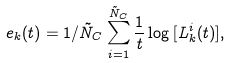Convert formula to latex. <formula><loc_0><loc_0><loc_500><loc_500>e _ { k } ( t ) = 1 / \tilde { N } _ { C } \sum _ { i = 1 } ^ { \tilde { N } _ { C } } \frac { 1 } { t } \log { [ L _ { k } ^ { i } ( t ) ] } ,</formula> 